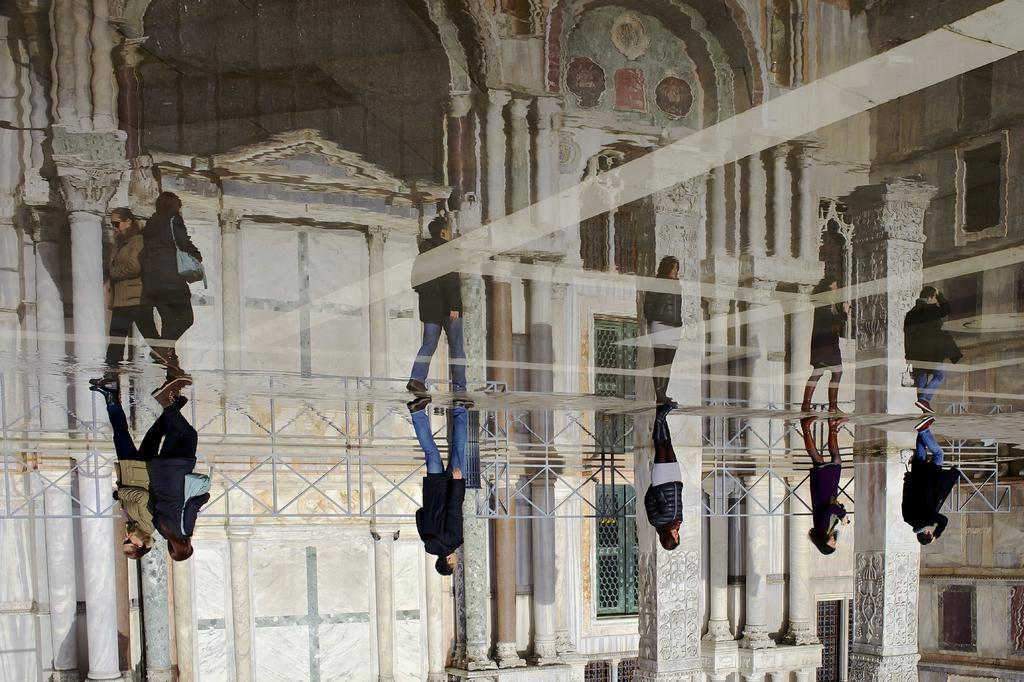What are the persons in the image doing? The persons in the image are walking. On what surface are the persons walking? The persons are walking on the floor. What natural element is visible in the image? There is water visible in the image. What can be seen in the background of the image? There is a building in the background of the image. What type of ornament is hanging from the ceiling in the image? There is no ornament hanging from the ceiling in the image. What type of house is visible in the image? There is no house visible in the image; it features a building in the background. 